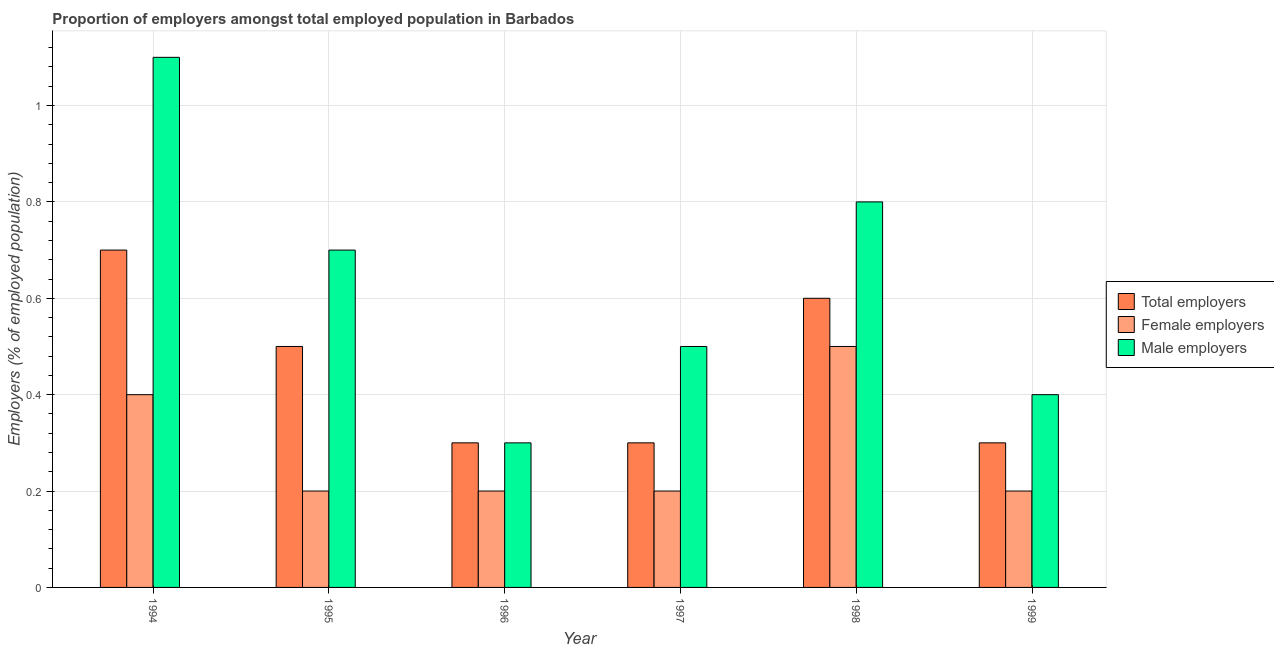How many different coloured bars are there?
Offer a very short reply. 3. How many groups of bars are there?
Your response must be concise. 6. How many bars are there on the 3rd tick from the right?
Keep it short and to the point. 3. What is the label of the 4th group of bars from the left?
Your answer should be very brief. 1997. In how many cases, is the number of bars for a given year not equal to the number of legend labels?
Provide a short and direct response. 0. What is the percentage of male employers in 1994?
Provide a short and direct response. 1.1. Across all years, what is the maximum percentage of total employers?
Your response must be concise. 0.7. Across all years, what is the minimum percentage of male employers?
Ensure brevity in your answer.  0.3. In which year was the percentage of male employers maximum?
Your answer should be very brief. 1994. In which year was the percentage of total employers minimum?
Offer a terse response. 1996. What is the total percentage of total employers in the graph?
Keep it short and to the point. 2.7. What is the difference between the percentage of total employers in 1995 and that in 1998?
Make the answer very short. -0.1. What is the difference between the percentage of male employers in 1999 and the percentage of female employers in 1996?
Make the answer very short. 0.1. What is the average percentage of female employers per year?
Your answer should be very brief. 0.28. In how many years, is the percentage of female employers greater than 0.36 %?
Offer a terse response. 2. Is the percentage of total employers in 1994 less than that in 1998?
Provide a short and direct response. No. Is the difference between the percentage of male employers in 1994 and 1999 greater than the difference between the percentage of total employers in 1994 and 1999?
Offer a terse response. No. What is the difference between the highest and the second highest percentage of female employers?
Provide a succinct answer. 0.1. What is the difference between the highest and the lowest percentage of male employers?
Your answer should be very brief. 0.8. What does the 3rd bar from the left in 1995 represents?
Offer a very short reply. Male employers. What does the 1st bar from the right in 1999 represents?
Your response must be concise. Male employers. Is it the case that in every year, the sum of the percentage of total employers and percentage of female employers is greater than the percentage of male employers?
Offer a very short reply. No. How many bars are there?
Your answer should be very brief. 18. Are all the bars in the graph horizontal?
Keep it short and to the point. No. Are the values on the major ticks of Y-axis written in scientific E-notation?
Provide a succinct answer. No. Does the graph contain any zero values?
Ensure brevity in your answer.  No. Does the graph contain grids?
Provide a short and direct response. Yes. How are the legend labels stacked?
Keep it short and to the point. Vertical. What is the title of the graph?
Give a very brief answer. Proportion of employers amongst total employed population in Barbados. What is the label or title of the Y-axis?
Provide a short and direct response. Employers (% of employed population). What is the Employers (% of employed population) in Total employers in 1994?
Your answer should be compact. 0.7. What is the Employers (% of employed population) in Female employers in 1994?
Your response must be concise. 0.4. What is the Employers (% of employed population) in Male employers in 1994?
Your answer should be very brief. 1.1. What is the Employers (% of employed population) in Total employers in 1995?
Provide a succinct answer. 0.5. What is the Employers (% of employed population) of Female employers in 1995?
Make the answer very short. 0.2. What is the Employers (% of employed population) of Male employers in 1995?
Ensure brevity in your answer.  0.7. What is the Employers (% of employed population) in Total employers in 1996?
Give a very brief answer. 0.3. What is the Employers (% of employed population) in Female employers in 1996?
Give a very brief answer. 0.2. What is the Employers (% of employed population) of Male employers in 1996?
Provide a succinct answer. 0.3. What is the Employers (% of employed population) of Total employers in 1997?
Offer a terse response. 0.3. What is the Employers (% of employed population) in Female employers in 1997?
Keep it short and to the point. 0.2. What is the Employers (% of employed population) of Male employers in 1997?
Give a very brief answer. 0.5. What is the Employers (% of employed population) of Total employers in 1998?
Offer a terse response. 0.6. What is the Employers (% of employed population) of Female employers in 1998?
Your answer should be very brief. 0.5. What is the Employers (% of employed population) of Male employers in 1998?
Offer a very short reply. 0.8. What is the Employers (% of employed population) in Total employers in 1999?
Keep it short and to the point. 0.3. What is the Employers (% of employed population) in Female employers in 1999?
Offer a very short reply. 0.2. What is the Employers (% of employed population) in Male employers in 1999?
Offer a very short reply. 0.4. Across all years, what is the maximum Employers (% of employed population) in Total employers?
Keep it short and to the point. 0.7. Across all years, what is the maximum Employers (% of employed population) in Male employers?
Ensure brevity in your answer.  1.1. Across all years, what is the minimum Employers (% of employed population) of Total employers?
Your response must be concise. 0.3. Across all years, what is the minimum Employers (% of employed population) of Female employers?
Ensure brevity in your answer.  0.2. Across all years, what is the minimum Employers (% of employed population) in Male employers?
Ensure brevity in your answer.  0.3. What is the total Employers (% of employed population) of Total employers in the graph?
Keep it short and to the point. 2.7. What is the difference between the Employers (% of employed population) in Total employers in 1994 and that in 1995?
Your response must be concise. 0.2. What is the difference between the Employers (% of employed population) of Female employers in 1994 and that in 1995?
Your answer should be very brief. 0.2. What is the difference between the Employers (% of employed population) of Male employers in 1994 and that in 1995?
Your answer should be compact. 0.4. What is the difference between the Employers (% of employed population) in Total employers in 1994 and that in 1996?
Make the answer very short. 0.4. What is the difference between the Employers (% of employed population) in Female employers in 1994 and that in 1996?
Make the answer very short. 0.2. What is the difference between the Employers (% of employed population) in Female employers in 1994 and that in 1998?
Your answer should be very brief. -0.1. What is the difference between the Employers (% of employed population) in Male employers in 1994 and that in 1998?
Provide a succinct answer. 0.3. What is the difference between the Employers (% of employed population) of Total employers in 1994 and that in 1999?
Give a very brief answer. 0.4. What is the difference between the Employers (% of employed population) of Female employers in 1994 and that in 1999?
Your answer should be compact. 0.2. What is the difference between the Employers (% of employed population) of Male employers in 1994 and that in 1999?
Provide a short and direct response. 0.7. What is the difference between the Employers (% of employed population) of Total employers in 1995 and that in 1996?
Your response must be concise. 0.2. What is the difference between the Employers (% of employed population) in Female employers in 1995 and that in 1996?
Provide a succinct answer. 0. What is the difference between the Employers (% of employed population) in Total employers in 1995 and that in 1997?
Give a very brief answer. 0.2. What is the difference between the Employers (% of employed population) in Female employers in 1995 and that in 1997?
Offer a terse response. 0. What is the difference between the Employers (% of employed population) in Male employers in 1995 and that in 1997?
Your answer should be compact. 0.2. What is the difference between the Employers (% of employed population) of Male employers in 1995 and that in 1998?
Offer a very short reply. -0.1. What is the difference between the Employers (% of employed population) of Female employers in 1995 and that in 1999?
Provide a succinct answer. 0. What is the difference between the Employers (% of employed population) in Female employers in 1996 and that in 1997?
Ensure brevity in your answer.  0. What is the difference between the Employers (% of employed population) in Male employers in 1996 and that in 1997?
Offer a very short reply. -0.2. What is the difference between the Employers (% of employed population) of Female employers in 1996 and that in 1998?
Provide a succinct answer. -0.3. What is the difference between the Employers (% of employed population) of Male employers in 1996 and that in 1998?
Provide a succinct answer. -0.5. What is the difference between the Employers (% of employed population) of Total employers in 1996 and that in 1999?
Your response must be concise. 0. What is the difference between the Employers (% of employed population) in Male employers in 1996 and that in 1999?
Provide a succinct answer. -0.1. What is the difference between the Employers (% of employed population) of Male employers in 1997 and that in 1998?
Offer a terse response. -0.3. What is the difference between the Employers (% of employed population) in Female employers in 1997 and that in 1999?
Offer a very short reply. 0. What is the difference between the Employers (% of employed population) of Male employers in 1997 and that in 1999?
Keep it short and to the point. 0.1. What is the difference between the Employers (% of employed population) in Male employers in 1998 and that in 1999?
Your response must be concise. 0.4. What is the difference between the Employers (% of employed population) of Total employers in 1994 and the Employers (% of employed population) of Male employers in 1995?
Your answer should be very brief. 0. What is the difference between the Employers (% of employed population) in Female employers in 1994 and the Employers (% of employed population) in Male employers in 1995?
Your response must be concise. -0.3. What is the difference between the Employers (% of employed population) of Female employers in 1994 and the Employers (% of employed population) of Male employers in 1996?
Offer a terse response. 0.1. What is the difference between the Employers (% of employed population) of Total employers in 1994 and the Employers (% of employed population) of Male employers in 1997?
Provide a succinct answer. 0.2. What is the difference between the Employers (% of employed population) in Female employers in 1994 and the Employers (% of employed population) in Male employers in 1997?
Offer a terse response. -0.1. What is the difference between the Employers (% of employed population) in Total employers in 1994 and the Employers (% of employed population) in Female employers in 1998?
Provide a succinct answer. 0.2. What is the difference between the Employers (% of employed population) of Total employers in 1994 and the Employers (% of employed population) of Male employers in 1998?
Your answer should be very brief. -0.1. What is the difference between the Employers (% of employed population) in Female employers in 1994 and the Employers (% of employed population) in Male employers in 1998?
Provide a succinct answer. -0.4. What is the difference between the Employers (% of employed population) of Total employers in 1994 and the Employers (% of employed population) of Female employers in 1999?
Provide a succinct answer. 0.5. What is the difference between the Employers (% of employed population) in Total employers in 1995 and the Employers (% of employed population) in Female employers in 1996?
Keep it short and to the point. 0.3. What is the difference between the Employers (% of employed population) in Total employers in 1995 and the Employers (% of employed population) in Male employers in 1996?
Keep it short and to the point. 0.2. What is the difference between the Employers (% of employed population) in Total employers in 1995 and the Employers (% of employed population) in Female employers in 1997?
Offer a very short reply. 0.3. What is the difference between the Employers (% of employed population) in Total employers in 1995 and the Employers (% of employed population) in Male employers in 1997?
Your answer should be very brief. 0. What is the difference between the Employers (% of employed population) of Female employers in 1995 and the Employers (% of employed population) of Male employers in 1998?
Your response must be concise. -0.6. What is the difference between the Employers (% of employed population) in Total employers in 1995 and the Employers (% of employed population) in Female employers in 1999?
Give a very brief answer. 0.3. What is the difference between the Employers (% of employed population) in Total employers in 1995 and the Employers (% of employed population) in Male employers in 1999?
Your answer should be compact. 0.1. What is the difference between the Employers (% of employed population) in Female employers in 1995 and the Employers (% of employed population) in Male employers in 1999?
Offer a terse response. -0.2. What is the difference between the Employers (% of employed population) of Total employers in 1996 and the Employers (% of employed population) of Female employers in 1997?
Your answer should be very brief. 0.1. What is the difference between the Employers (% of employed population) in Total employers in 1996 and the Employers (% of employed population) in Male employers in 1997?
Give a very brief answer. -0.2. What is the difference between the Employers (% of employed population) in Female employers in 1996 and the Employers (% of employed population) in Male employers in 1997?
Offer a terse response. -0.3. What is the difference between the Employers (% of employed population) in Total employers in 1996 and the Employers (% of employed population) in Female employers in 1998?
Give a very brief answer. -0.2. What is the difference between the Employers (% of employed population) of Total employers in 1996 and the Employers (% of employed population) of Male employers in 1998?
Make the answer very short. -0.5. What is the difference between the Employers (% of employed population) in Female employers in 1996 and the Employers (% of employed population) in Male employers in 1998?
Your answer should be compact. -0.6. What is the difference between the Employers (% of employed population) in Total employers in 1996 and the Employers (% of employed population) in Female employers in 1999?
Give a very brief answer. 0.1. What is the difference between the Employers (% of employed population) in Total employers in 1997 and the Employers (% of employed population) in Female employers in 1998?
Offer a very short reply. -0.2. What is the difference between the Employers (% of employed population) of Total employers in 1997 and the Employers (% of employed population) of Male employers in 1998?
Your response must be concise. -0.5. What is the difference between the Employers (% of employed population) in Female employers in 1997 and the Employers (% of employed population) in Male employers in 1998?
Offer a terse response. -0.6. What is the difference between the Employers (% of employed population) of Total employers in 1997 and the Employers (% of employed population) of Female employers in 1999?
Give a very brief answer. 0.1. What is the difference between the Employers (% of employed population) in Female employers in 1997 and the Employers (% of employed population) in Male employers in 1999?
Offer a terse response. -0.2. What is the average Employers (% of employed population) in Total employers per year?
Your response must be concise. 0.45. What is the average Employers (% of employed population) of Female employers per year?
Ensure brevity in your answer.  0.28. What is the average Employers (% of employed population) of Male employers per year?
Provide a short and direct response. 0.63. In the year 1995, what is the difference between the Employers (% of employed population) of Total employers and Employers (% of employed population) of Female employers?
Make the answer very short. 0.3. In the year 1995, what is the difference between the Employers (% of employed population) in Female employers and Employers (% of employed population) in Male employers?
Ensure brevity in your answer.  -0.5. In the year 1997, what is the difference between the Employers (% of employed population) in Total employers and Employers (% of employed population) in Female employers?
Provide a short and direct response. 0.1. In the year 1998, what is the difference between the Employers (% of employed population) in Total employers and Employers (% of employed population) in Female employers?
Your answer should be compact. 0.1. In the year 1999, what is the difference between the Employers (% of employed population) in Total employers and Employers (% of employed population) in Female employers?
Your response must be concise. 0.1. In the year 1999, what is the difference between the Employers (% of employed population) in Total employers and Employers (% of employed population) in Male employers?
Make the answer very short. -0.1. In the year 1999, what is the difference between the Employers (% of employed population) in Female employers and Employers (% of employed population) in Male employers?
Keep it short and to the point. -0.2. What is the ratio of the Employers (% of employed population) in Total employers in 1994 to that in 1995?
Your response must be concise. 1.4. What is the ratio of the Employers (% of employed population) of Male employers in 1994 to that in 1995?
Give a very brief answer. 1.57. What is the ratio of the Employers (% of employed population) of Total employers in 1994 to that in 1996?
Make the answer very short. 2.33. What is the ratio of the Employers (% of employed population) in Male employers in 1994 to that in 1996?
Ensure brevity in your answer.  3.67. What is the ratio of the Employers (% of employed population) in Total employers in 1994 to that in 1997?
Ensure brevity in your answer.  2.33. What is the ratio of the Employers (% of employed population) of Female employers in 1994 to that in 1997?
Keep it short and to the point. 2. What is the ratio of the Employers (% of employed population) of Total employers in 1994 to that in 1998?
Keep it short and to the point. 1.17. What is the ratio of the Employers (% of employed population) in Male employers in 1994 to that in 1998?
Your answer should be compact. 1.38. What is the ratio of the Employers (% of employed population) of Total employers in 1994 to that in 1999?
Make the answer very short. 2.33. What is the ratio of the Employers (% of employed population) of Female employers in 1994 to that in 1999?
Make the answer very short. 2. What is the ratio of the Employers (% of employed population) in Male employers in 1994 to that in 1999?
Ensure brevity in your answer.  2.75. What is the ratio of the Employers (% of employed population) of Male employers in 1995 to that in 1996?
Offer a terse response. 2.33. What is the ratio of the Employers (% of employed population) in Male employers in 1995 to that in 1997?
Provide a succinct answer. 1.4. What is the ratio of the Employers (% of employed population) in Total employers in 1995 to that in 1998?
Provide a short and direct response. 0.83. What is the ratio of the Employers (% of employed population) in Female employers in 1995 to that in 1998?
Give a very brief answer. 0.4. What is the ratio of the Employers (% of employed population) in Total employers in 1995 to that in 1999?
Ensure brevity in your answer.  1.67. What is the ratio of the Employers (% of employed population) in Female employers in 1995 to that in 1999?
Offer a very short reply. 1. What is the ratio of the Employers (% of employed population) in Total employers in 1996 to that in 1997?
Keep it short and to the point. 1. What is the ratio of the Employers (% of employed population) of Female employers in 1996 to that in 1997?
Make the answer very short. 1. What is the ratio of the Employers (% of employed population) of Total employers in 1996 to that in 1998?
Provide a short and direct response. 0.5. What is the ratio of the Employers (% of employed population) in Total employers in 1997 to that in 1998?
Your response must be concise. 0.5. What is the ratio of the Employers (% of employed population) of Male employers in 1997 to that in 1998?
Provide a succinct answer. 0.62. What is the ratio of the Employers (% of employed population) in Total employers in 1997 to that in 1999?
Your answer should be very brief. 1. What is the ratio of the Employers (% of employed population) of Male employers in 1997 to that in 1999?
Your answer should be very brief. 1.25. 